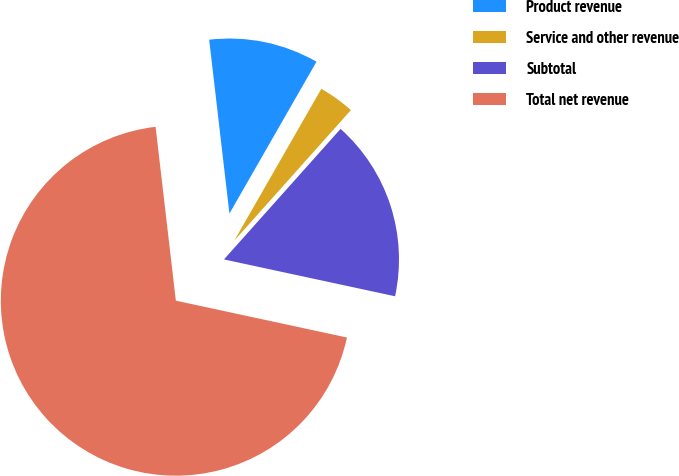Convert chart to OTSL. <chart><loc_0><loc_0><loc_500><loc_500><pie_chart><fcel>Product revenue<fcel>Service and other revenue<fcel>Subtotal<fcel>Total net revenue<nl><fcel>10.13%<fcel>3.32%<fcel>16.77%<fcel>69.77%<nl></chart> 